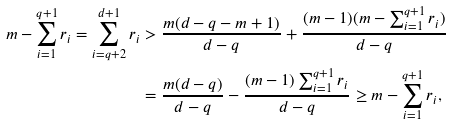Convert formula to latex. <formula><loc_0><loc_0><loc_500><loc_500>m - \sum _ { i = 1 } ^ { q + 1 } r _ { i } = \sum _ { i = q + 2 } ^ { d + 1 } r _ { i } & > \frac { m ( d - q - m + 1 ) } { d - q } + \frac { ( m - 1 ) ( m - \sum _ { i = 1 } ^ { q + 1 } r _ { i } ) } { d - q } \\ & = \frac { m ( d - q ) } { d - q } - \frac { ( m - 1 ) \sum _ { i = 1 } ^ { q + 1 } r _ { i } } { d - q } \geq m - \sum _ { i = 1 } ^ { q + 1 } r _ { i } ,</formula> 